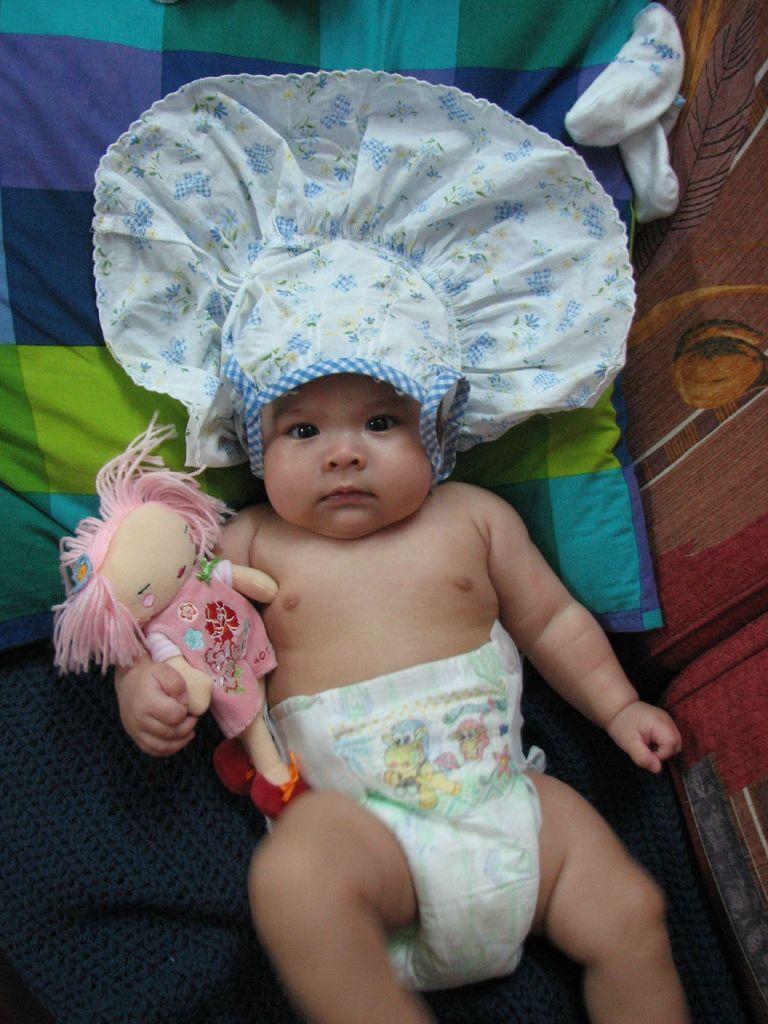Could you give a brief overview of what you see in this image? In this image in front there is a baby. Behind him there is a doll and we can see a pillow on the bed. 